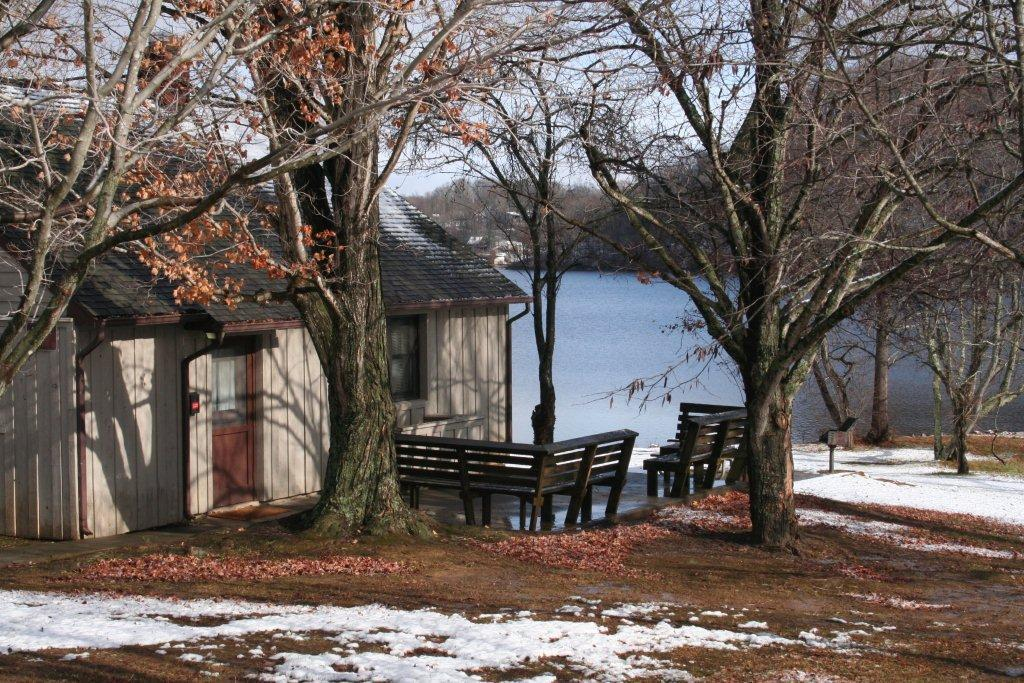What type of structure is located beside the lake in the image? There is a shelter house beside the lake in the image. What can be seen in the background of the image? There are trees in the image. What type of seating is available in the middle of the image? There are benches in the middle of the image. How does the paste stick to the trees in the image? There is no paste present in the image; it only features a shelter house, trees, and benches. 